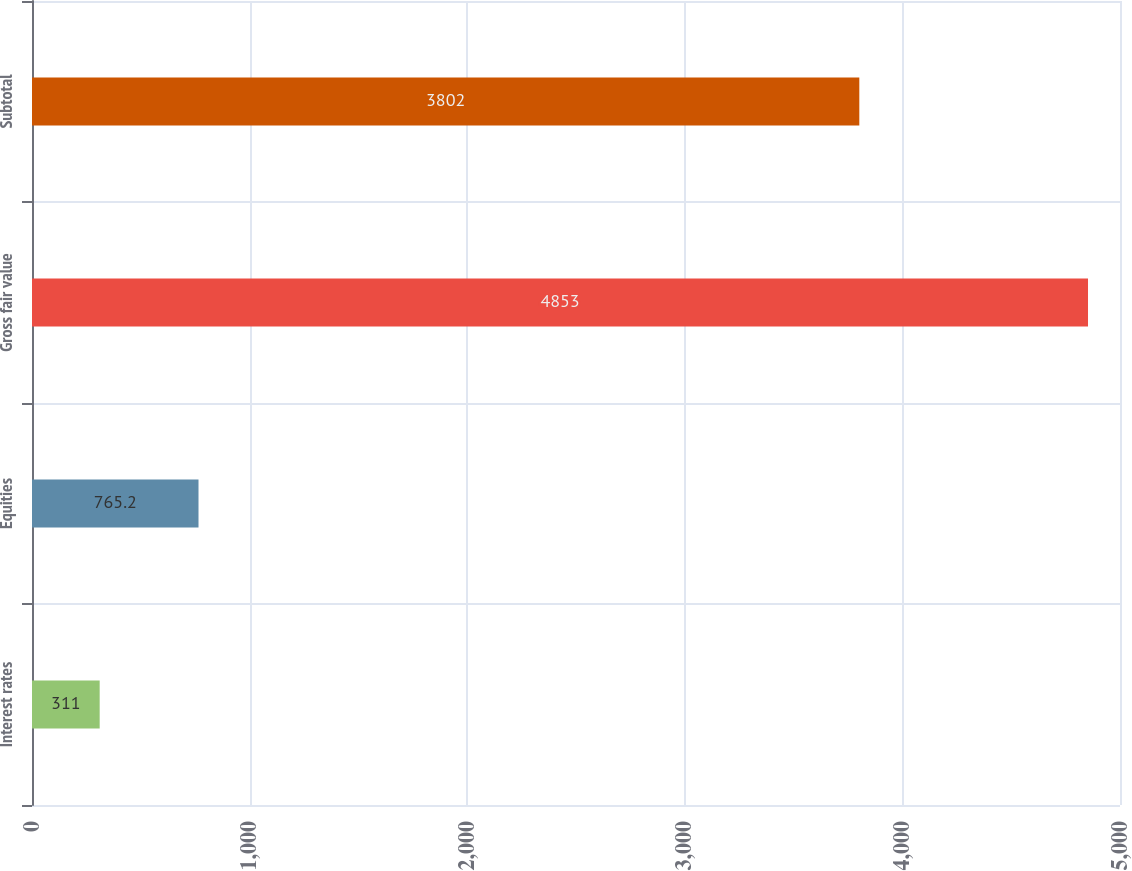Convert chart. <chart><loc_0><loc_0><loc_500><loc_500><bar_chart><fcel>Interest rates<fcel>Equities<fcel>Gross fair value<fcel>Subtotal<nl><fcel>311<fcel>765.2<fcel>4853<fcel>3802<nl></chart> 